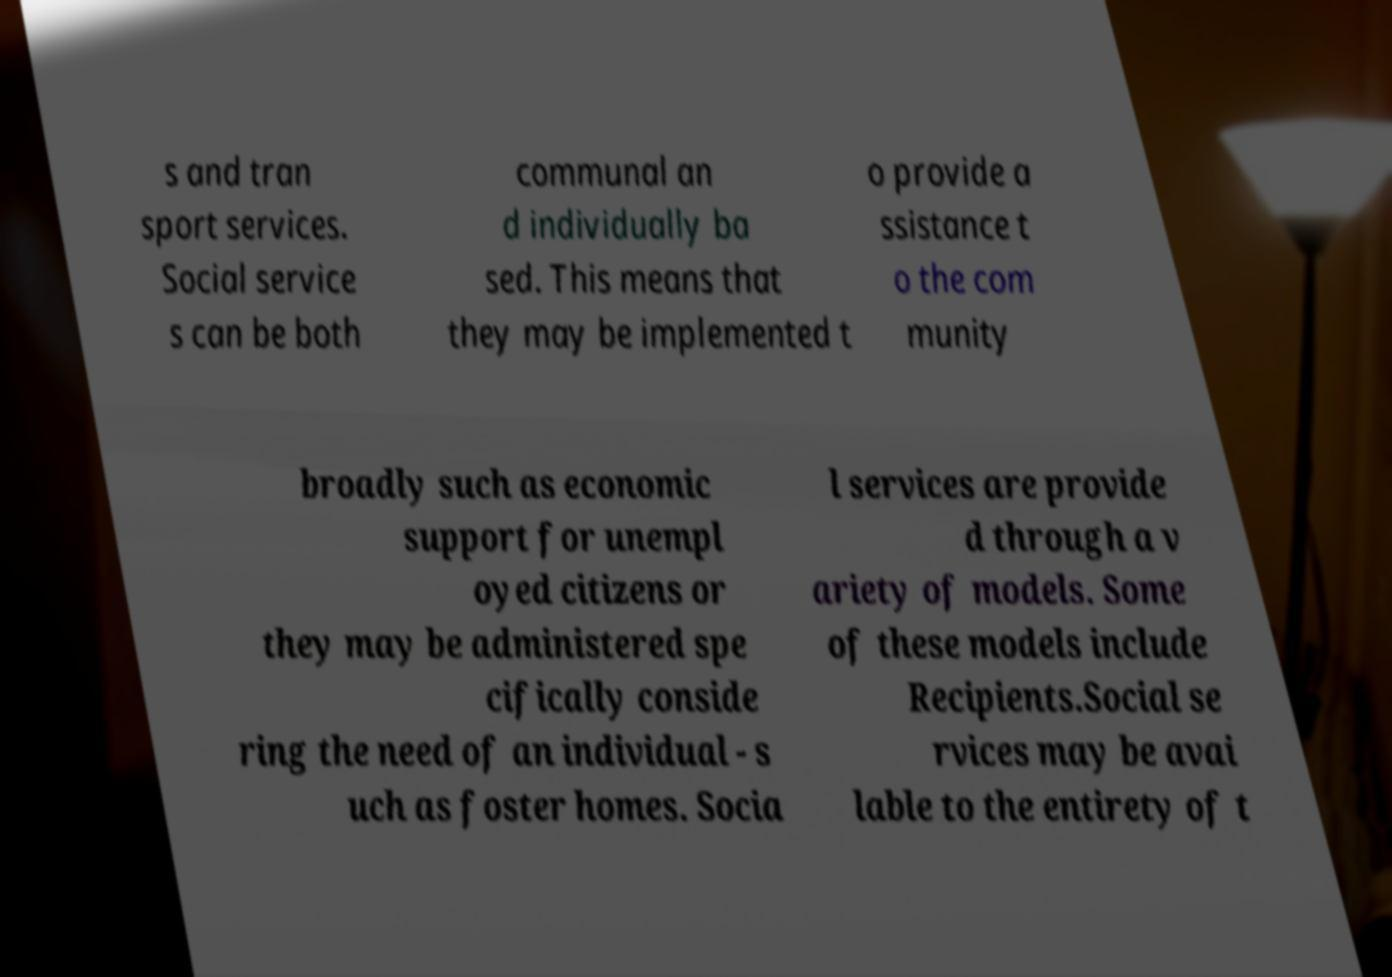For documentation purposes, I need the text within this image transcribed. Could you provide that? s and tran sport services. Social service s can be both communal an d individually ba sed. This means that they may be implemented t o provide a ssistance t o the com munity broadly such as economic support for unempl oyed citizens or they may be administered spe cifically conside ring the need of an individual - s uch as foster homes. Socia l services are provide d through a v ariety of models. Some of these models include Recipients.Social se rvices may be avai lable to the entirety of t 